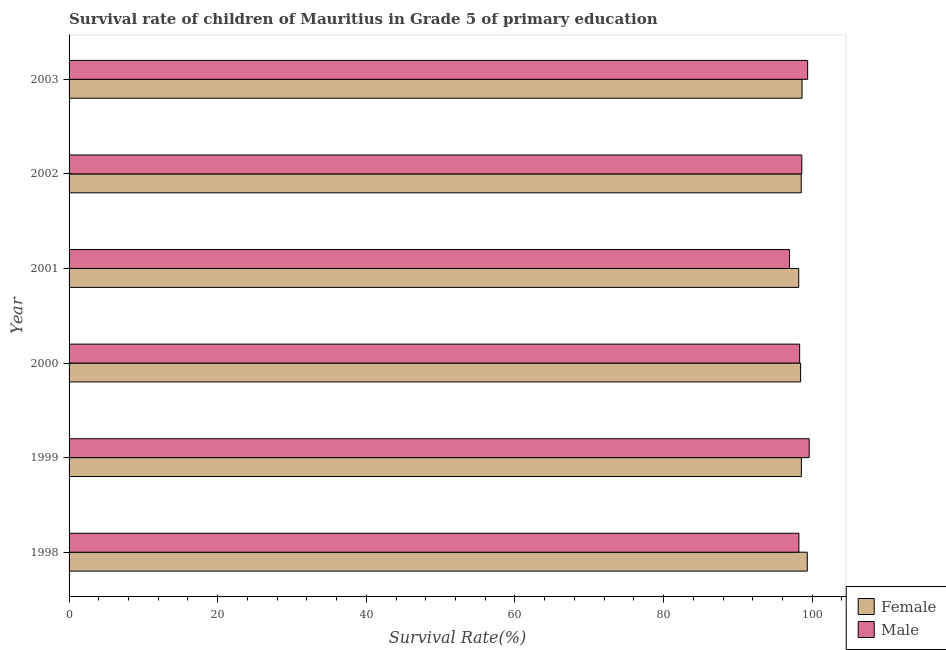How many different coloured bars are there?
Offer a very short reply. 2. How many groups of bars are there?
Your answer should be very brief. 6. Are the number of bars per tick equal to the number of legend labels?
Make the answer very short. Yes. Are the number of bars on each tick of the Y-axis equal?
Provide a short and direct response. Yes. How many bars are there on the 2nd tick from the bottom?
Give a very brief answer. 2. In how many cases, is the number of bars for a given year not equal to the number of legend labels?
Keep it short and to the point. 0. What is the survival rate of male students in primary education in 1998?
Provide a short and direct response. 98.21. Across all years, what is the maximum survival rate of male students in primary education?
Make the answer very short. 99.59. Across all years, what is the minimum survival rate of female students in primary education?
Ensure brevity in your answer.  98.19. What is the total survival rate of female students in primary education in the graph?
Your answer should be very brief. 591.65. What is the difference between the survival rate of female students in primary education in 1999 and that in 2003?
Your answer should be very brief. -0.09. What is the difference between the survival rate of male students in primary education in 2003 and the survival rate of female students in primary education in 1999?
Your answer should be very brief. 0.84. What is the average survival rate of male students in primary education per year?
Your response must be concise. 98.51. In the year 2000, what is the difference between the survival rate of male students in primary education and survival rate of female students in primary education?
Your answer should be very brief. -0.13. What is the difference between the highest and the second highest survival rate of female students in primary education?
Give a very brief answer. 0.7. What is the difference between the highest and the lowest survival rate of female students in primary education?
Ensure brevity in your answer.  1.15. Is the sum of the survival rate of female students in primary education in 2000 and 2003 greater than the maximum survival rate of male students in primary education across all years?
Keep it short and to the point. Yes. What does the 2nd bar from the top in 1998 represents?
Keep it short and to the point. Female. Are all the bars in the graph horizontal?
Offer a terse response. Yes. What is the title of the graph?
Your answer should be compact. Survival rate of children of Mauritius in Grade 5 of primary education. Does "Study and work" appear as one of the legend labels in the graph?
Your response must be concise. No. What is the label or title of the X-axis?
Give a very brief answer. Survival Rate(%). What is the label or title of the Y-axis?
Give a very brief answer. Year. What is the Survival Rate(%) in Female in 1998?
Provide a short and direct response. 99.34. What is the Survival Rate(%) of Male in 1998?
Make the answer very short. 98.21. What is the Survival Rate(%) in Female in 1999?
Ensure brevity in your answer.  98.54. What is the Survival Rate(%) in Male in 1999?
Offer a terse response. 99.59. What is the Survival Rate(%) in Female in 2000?
Offer a terse response. 98.44. What is the Survival Rate(%) of Male in 2000?
Make the answer very short. 98.31. What is the Survival Rate(%) in Female in 2001?
Offer a terse response. 98.19. What is the Survival Rate(%) in Male in 2001?
Give a very brief answer. 96.95. What is the Survival Rate(%) in Female in 2002?
Your answer should be very brief. 98.52. What is the Survival Rate(%) in Male in 2002?
Ensure brevity in your answer.  98.6. What is the Survival Rate(%) in Female in 2003?
Offer a very short reply. 98.63. What is the Survival Rate(%) in Male in 2003?
Make the answer very short. 99.39. Across all years, what is the maximum Survival Rate(%) of Female?
Give a very brief answer. 99.34. Across all years, what is the maximum Survival Rate(%) of Male?
Ensure brevity in your answer.  99.59. Across all years, what is the minimum Survival Rate(%) of Female?
Make the answer very short. 98.19. Across all years, what is the minimum Survival Rate(%) in Male?
Provide a succinct answer. 96.95. What is the total Survival Rate(%) of Female in the graph?
Offer a very short reply. 591.65. What is the total Survival Rate(%) of Male in the graph?
Make the answer very short. 591.04. What is the difference between the Survival Rate(%) of Female in 1998 and that in 1999?
Your answer should be very brief. 0.8. What is the difference between the Survival Rate(%) in Male in 1998 and that in 1999?
Offer a very short reply. -1.39. What is the difference between the Survival Rate(%) in Female in 1998 and that in 2000?
Provide a short and direct response. 0.9. What is the difference between the Survival Rate(%) in Male in 1998 and that in 2000?
Offer a terse response. -0.1. What is the difference between the Survival Rate(%) in Female in 1998 and that in 2001?
Your answer should be compact. 1.15. What is the difference between the Survival Rate(%) in Male in 1998 and that in 2001?
Provide a succinct answer. 1.26. What is the difference between the Survival Rate(%) of Female in 1998 and that in 2002?
Provide a short and direct response. 0.81. What is the difference between the Survival Rate(%) of Male in 1998 and that in 2002?
Make the answer very short. -0.39. What is the difference between the Survival Rate(%) in Female in 1998 and that in 2003?
Keep it short and to the point. 0.7. What is the difference between the Survival Rate(%) of Male in 1998 and that in 2003?
Give a very brief answer. -1.18. What is the difference between the Survival Rate(%) in Female in 1999 and that in 2000?
Offer a very short reply. 0.11. What is the difference between the Survival Rate(%) in Male in 1999 and that in 2000?
Your response must be concise. 1.28. What is the difference between the Survival Rate(%) of Female in 1999 and that in 2001?
Ensure brevity in your answer.  0.36. What is the difference between the Survival Rate(%) in Male in 1999 and that in 2001?
Keep it short and to the point. 2.65. What is the difference between the Survival Rate(%) of Female in 1999 and that in 2002?
Your response must be concise. 0.02. What is the difference between the Survival Rate(%) of Female in 1999 and that in 2003?
Your answer should be compact. -0.09. What is the difference between the Survival Rate(%) in Male in 1999 and that in 2003?
Provide a short and direct response. 0.21. What is the difference between the Survival Rate(%) in Female in 2000 and that in 2001?
Provide a short and direct response. 0.25. What is the difference between the Survival Rate(%) in Male in 2000 and that in 2001?
Your response must be concise. 1.36. What is the difference between the Survival Rate(%) in Female in 2000 and that in 2002?
Keep it short and to the point. -0.09. What is the difference between the Survival Rate(%) of Male in 2000 and that in 2002?
Make the answer very short. -0.29. What is the difference between the Survival Rate(%) in Female in 2000 and that in 2003?
Make the answer very short. -0.2. What is the difference between the Survival Rate(%) in Male in 2000 and that in 2003?
Make the answer very short. -1.08. What is the difference between the Survival Rate(%) in Female in 2001 and that in 2002?
Make the answer very short. -0.34. What is the difference between the Survival Rate(%) in Male in 2001 and that in 2002?
Give a very brief answer. -1.66. What is the difference between the Survival Rate(%) in Female in 2001 and that in 2003?
Keep it short and to the point. -0.45. What is the difference between the Survival Rate(%) in Male in 2001 and that in 2003?
Give a very brief answer. -2.44. What is the difference between the Survival Rate(%) of Female in 2002 and that in 2003?
Provide a succinct answer. -0.11. What is the difference between the Survival Rate(%) of Male in 2002 and that in 2003?
Your answer should be very brief. -0.79. What is the difference between the Survival Rate(%) of Female in 1998 and the Survival Rate(%) of Male in 1999?
Ensure brevity in your answer.  -0.26. What is the difference between the Survival Rate(%) of Female in 1998 and the Survival Rate(%) of Male in 2000?
Keep it short and to the point. 1.03. What is the difference between the Survival Rate(%) in Female in 1998 and the Survival Rate(%) in Male in 2001?
Provide a short and direct response. 2.39. What is the difference between the Survival Rate(%) in Female in 1998 and the Survival Rate(%) in Male in 2002?
Your answer should be compact. 0.74. What is the difference between the Survival Rate(%) in Female in 1998 and the Survival Rate(%) in Male in 2003?
Provide a succinct answer. -0.05. What is the difference between the Survival Rate(%) in Female in 1999 and the Survival Rate(%) in Male in 2000?
Offer a very short reply. 0.23. What is the difference between the Survival Rate(%) of Female in 1999 and the Survival Rate(%) of Male in 2001?
Ensure brevity in your answer.  1.6. What is the difference between the Survival Rate(%) of Female in 1999 and the Survival Rate(%) of Male in 2002?
Give a very brief answer. -0.06. What is the difference between the Survival Rate(%) of Female in 1999 and the Survival Rate(%) of Male in 2003?
Keep it short and to the point. -0.84. What is the difference between the Survival Rate(%) of Female in 2000 and the Survival Rate(%) of Male in 2001?
Your response must be concise. 1.49. What is the difference between the Survival Rate(%) in Female in 2000 and the Survival Rate(%) in Male in 2002?
Keep it short and to the point. -0.16. What is the difference between the Survival Rate(%) in Female in 2000 and the Survival Rate(%) in Male in 2003?
Provide a short and direct response. -0.95. What is the difference between the Survival Rate(%) in Female in 2001 and the Survival Rate(%) in Male in 2002?
Your response must be concise. -0.42. What is the difference between the Survival Rate(%) of Female in 2001 and the Survival Rate(%) of Male in 2003?
Your answer should be compact. -1.2. What is the difference between the Survival Rate(%) in Female in 2002 and the Survival Rate(%) in Male in 2003?
Offer a very short reply. -0.86. What is the average Survival Rate(%) of Female per year?
Ensure brevity in your answer.  98.61. What is the average Survival Rate(%) in Male per year?
Give a very brief answer. 98.51. In the year 1998, what is the difference between the Survival Rate(%) in Female and Survival Rate(%) in Male?
Your answer should be compact. 1.13. In the year 1999, what is the difference between the Survival Rate(%) of Female and Survival Rate(%) of Male?
Provide a short and direct response. -1.05. In the year 2000, what is the difference between the Survival Rate(%) of Female and Survival Rate(%) of Male?
Offer a very short reply. 0.13. In the year 2001, what is the difference between the Survival Rate(%) in Female and Survival Rate(%) in Male?
Provide a short and direct response. 1.24. In the year 2002, what is the difference between the Survival Rate(%) in Female and Survival Rate(%) in Male?
Provide a short and direct response. -0.08. In the year 2003, what is the difference between the Survival Rate(%) of Female and Survival Rate(%) of Male?
Make the answer very short. -0.75. What is the ratio of the Survival Rate(%) of Male in 1998 to that in 1999?
Provide a short and direct response. 0.99. What is the ratio of the Survival Rate(%) in Female in 1998 to that in 2000?
Keep it short and to the point. 1.01. What is the ratio of the Survival Rate(%) of Female in 1998 to that in 2001?
Offer a very short reply. 1.01. What is the ratio of the Survival Rate(%) in Female in 1998 to that in 2002?
Your response must be concise. 1.01. What is the ratio of the Survival Rate(%) in Male in 1998 to that in 2002?
Provide a succinct answer. 1. What is the ratio of the Survival Rate(%) in Female in 1998 to that in 2003?
Ensure brevity in your answer.  1.01. What is the ratio of the Survival Rate(%) of Male in 1998 to that in 2003?
Give a very brief answer. 0.99. What is the ratio of the Survival Rate(%) in Female in 1999 to that in 2000?
Offer a very short reply. 1. What is the ratio of the Survival Rate(%) of Male in 1999 to that in 2000?
Give a very brief answer. 1.01. What is the ratio of the Survival Rate(%) in Female in 1999 to that in 2001?
Your answer should be very brief. 1. What is the ratio of the Survival Rate(%) of Male in 1999 to that in 2001?
Your answer should be very brief. 1.03. What is the ratio of the Survival Rate(%) of Male in 1999 to that in 2002?
Offer a very short reply. 1.01. What is the ratio of the Survival Rate(%) in Female in 1999 to that in 2003?
Your response must be concise. 1. What is the ratio of the Survival Rate(%) in Male in 1999 to that in 2003?
Your answer should be very brief. 1. What is the ratio of the Survival Rate(%) in Female in 2000 to that in 2001?
Provide a short and direct response. 1. What is the ratio of the Survival Rate(%) in Male in 2000 to that in 2001?
Provide a succinct answer. 1.01. What is the ratio of the Survival Rate(%) of Female in 2000 to that in 2002?
Provide a short and direct response. 1. What is the ratio of the Survival Rate(%) of Male in 2000 to that in 2002?
Give a very brief answer. 1. What is the ratio of the Survival Rate(%) in Female in 2000 to that in 2003?
Keep it short and to the point. 1. What is the ratio of the Survival Rate(%) of Female in 2001 to that in 2002?
Offer a very short reply. 1. What is the ratio of the Survival Rate(%) of Male in 2001 to that in 2002?
Provide a succinct answer. 0.98. What is the ratio of the Survival Rate(%) in Male in 2001 to that in 2003?
Give a very brief answer. 0.98. What is the ratio of the Survival Rate(%) in Female in 2002 to that in 2003?
Keep it short and to the point. 1. What is the difference between the highest and the second highest Survival Rate(%) in Female?
Offer a terse response. 0.7. What is the difference between the highest and the second highest Survival Rate(%) in Male?
Provide a succinct answer. 0.21. What is the difference between the highest and the lowest Survival Rate(%) in Female?
Offer a terse response. 1.15. What is the difference between the highest and the lowest Survival Rate(%) of Male?
Your answer should be compact. 2.65. 